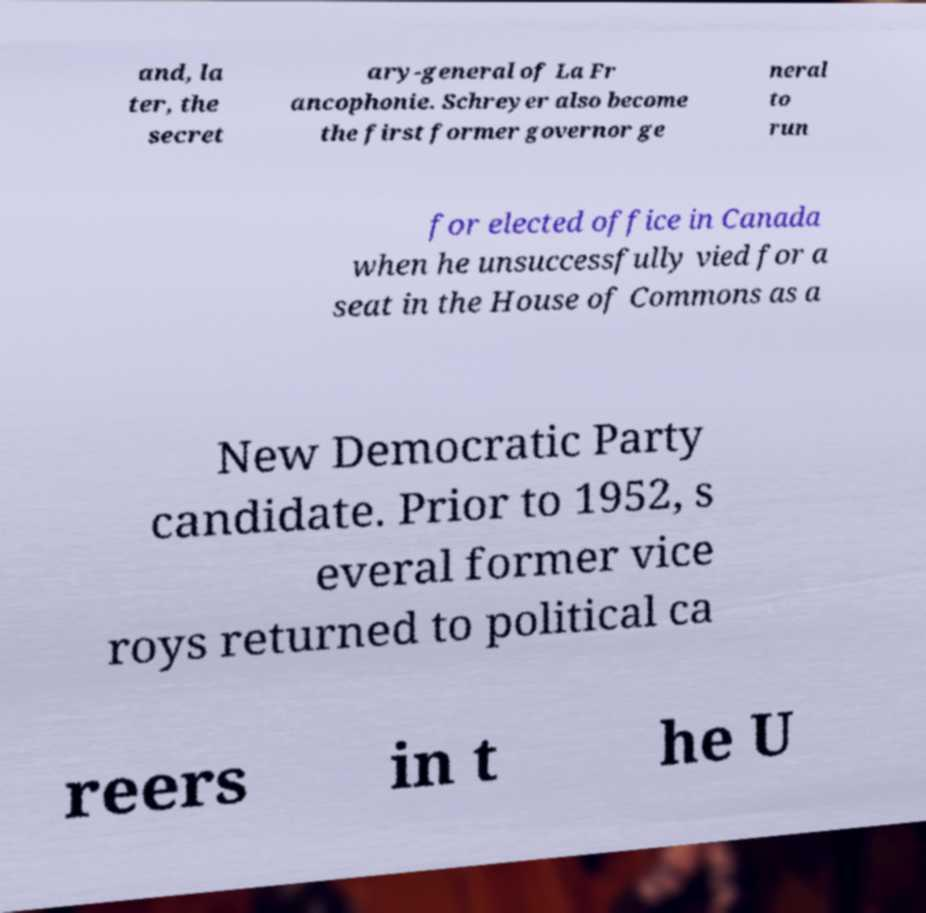There's text embedded in this image that I need extracted. Can you transcribe it verbatim? and, la ter, the secret ary-general of La Fr ancophonie. Schreyer also become the first former governor ge neral to run for elected office in Canada when he unsuccessfully vied for a seat in the House of Commons as a New Democratic Party candidate. Prior to 1952, s everal former vice roys returned to political ca reers in t he U 